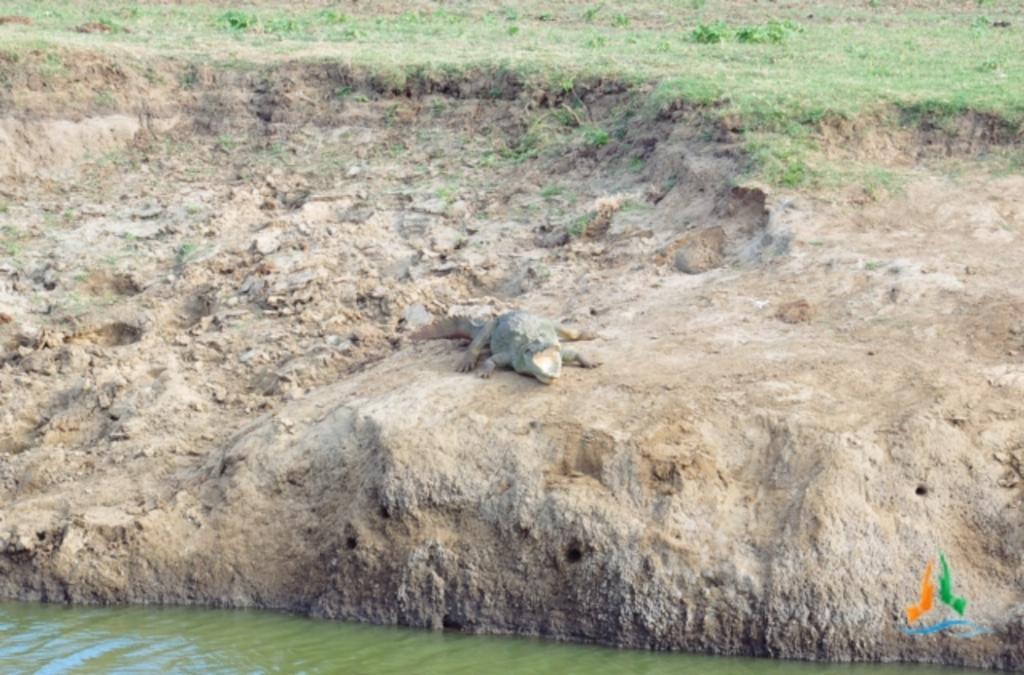Could you give a brief overview of what you see in this image? At the bottom of the picture, we see water and this water might be in the pond. In the middle of the picture, we see the crocodile. In the background, we see the grass. 